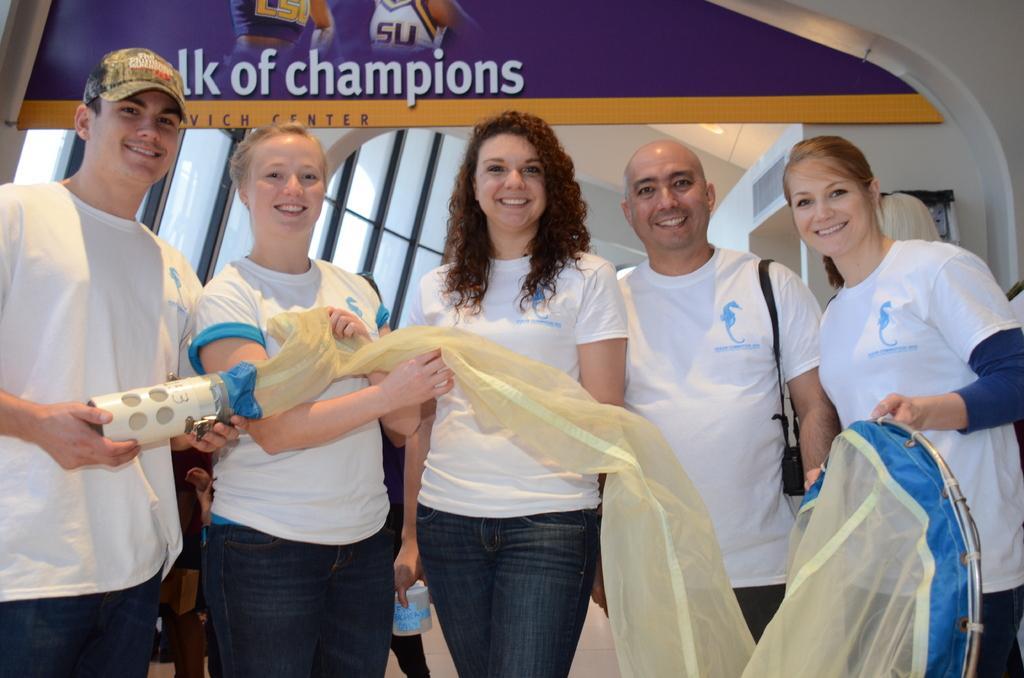Could you give a brief overview of what you see in this image? In this picture there is a group of men and women wearing a white color t-shirt holding the net in the hand, smiling and giving a pose into the camera. Behind there is a blue color banner on which "Champion" is written. 